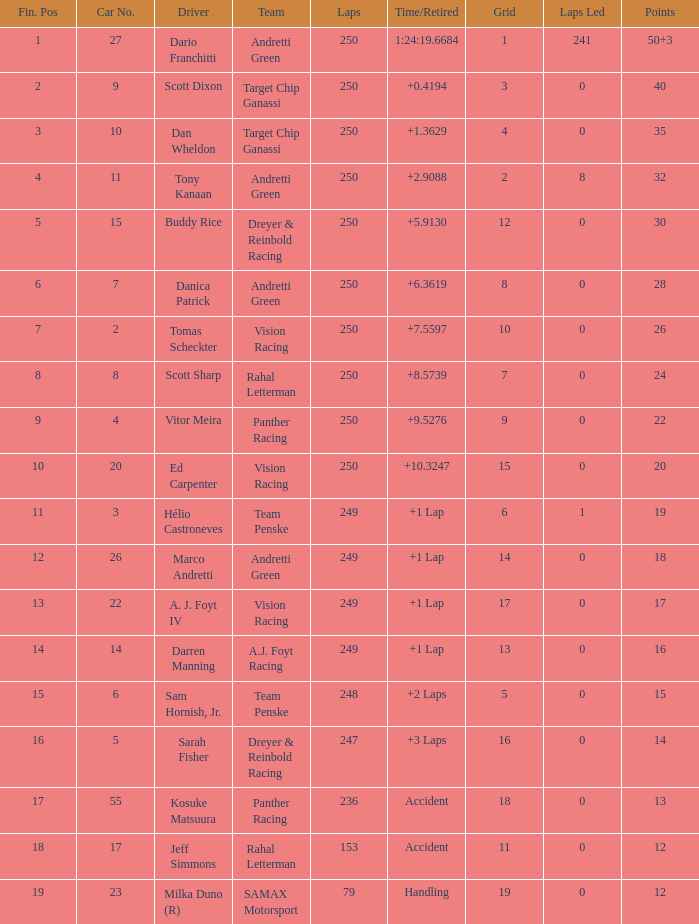Identify the overall sum of cars for panther racing and a 9-grid. 1.0. 